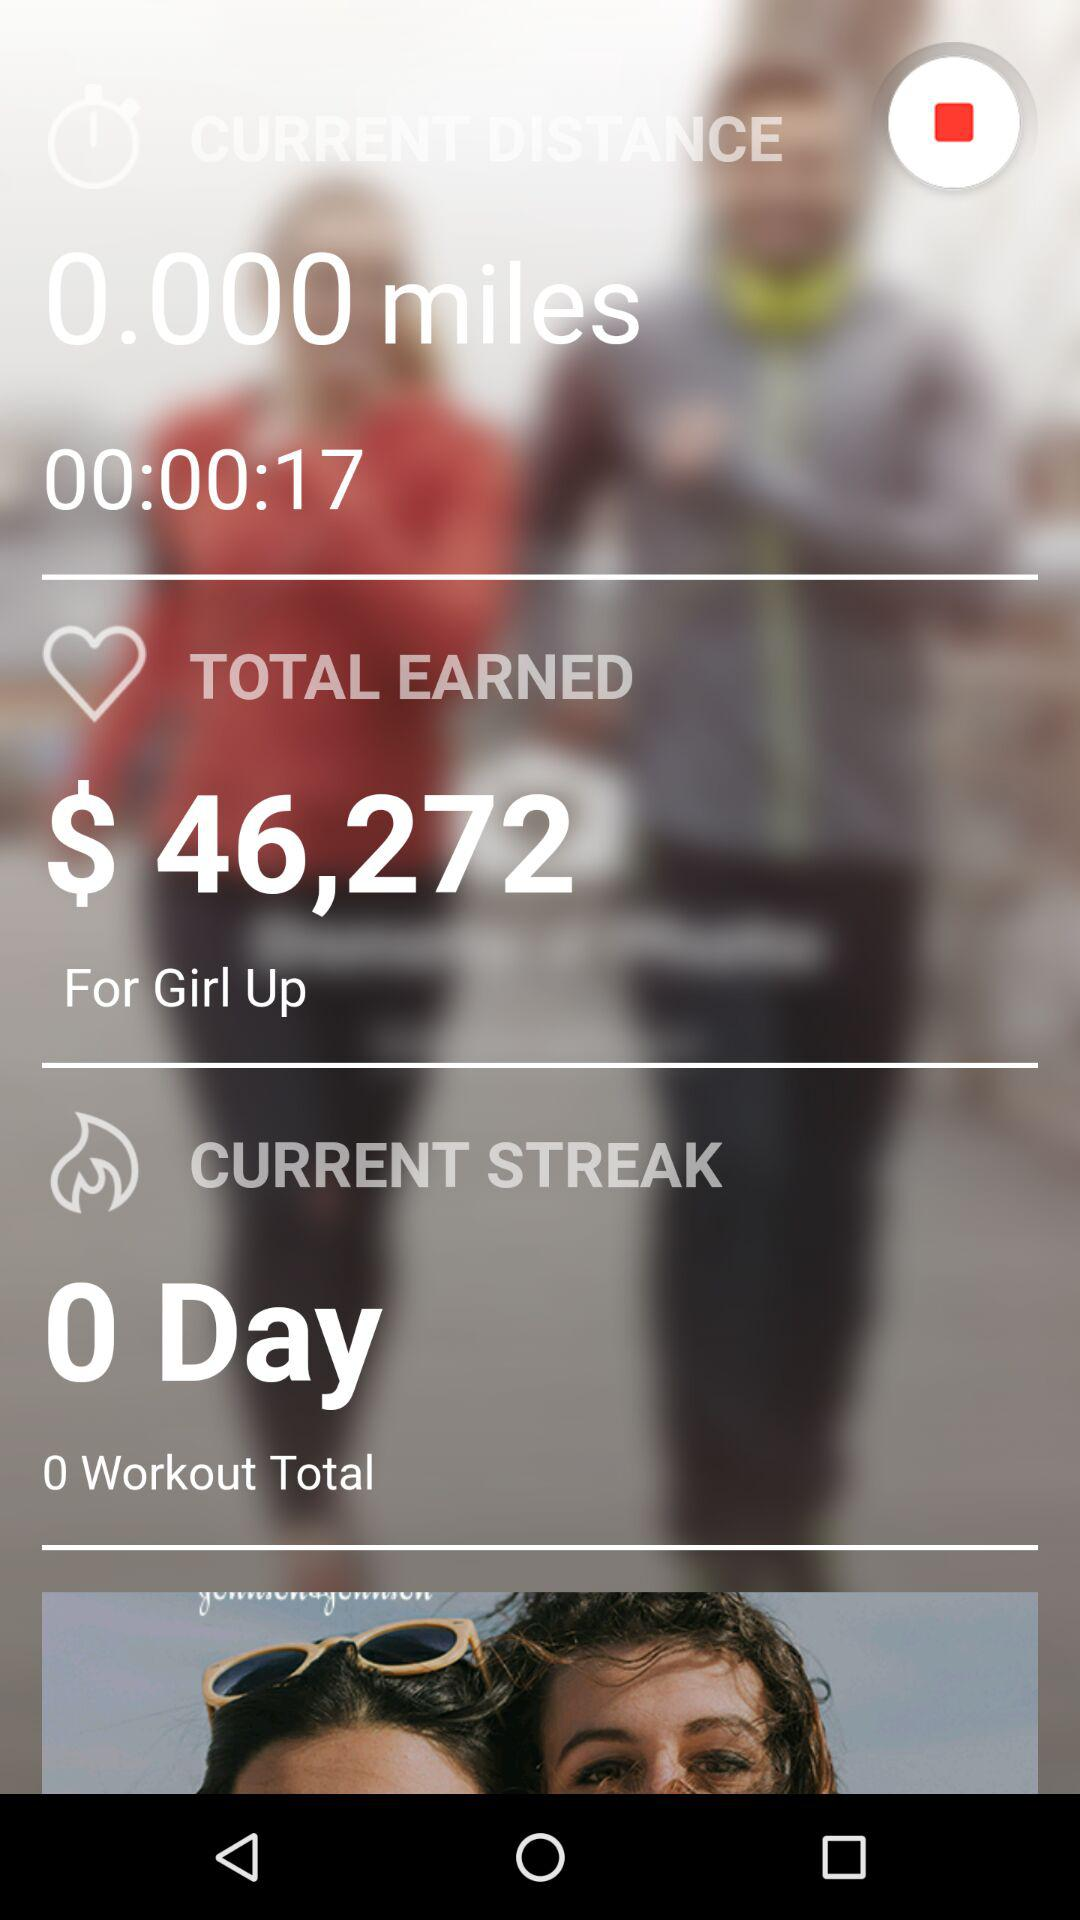How much more total earnings do I have than my current distance?
Answer the question using a single word or phrase. 46272 